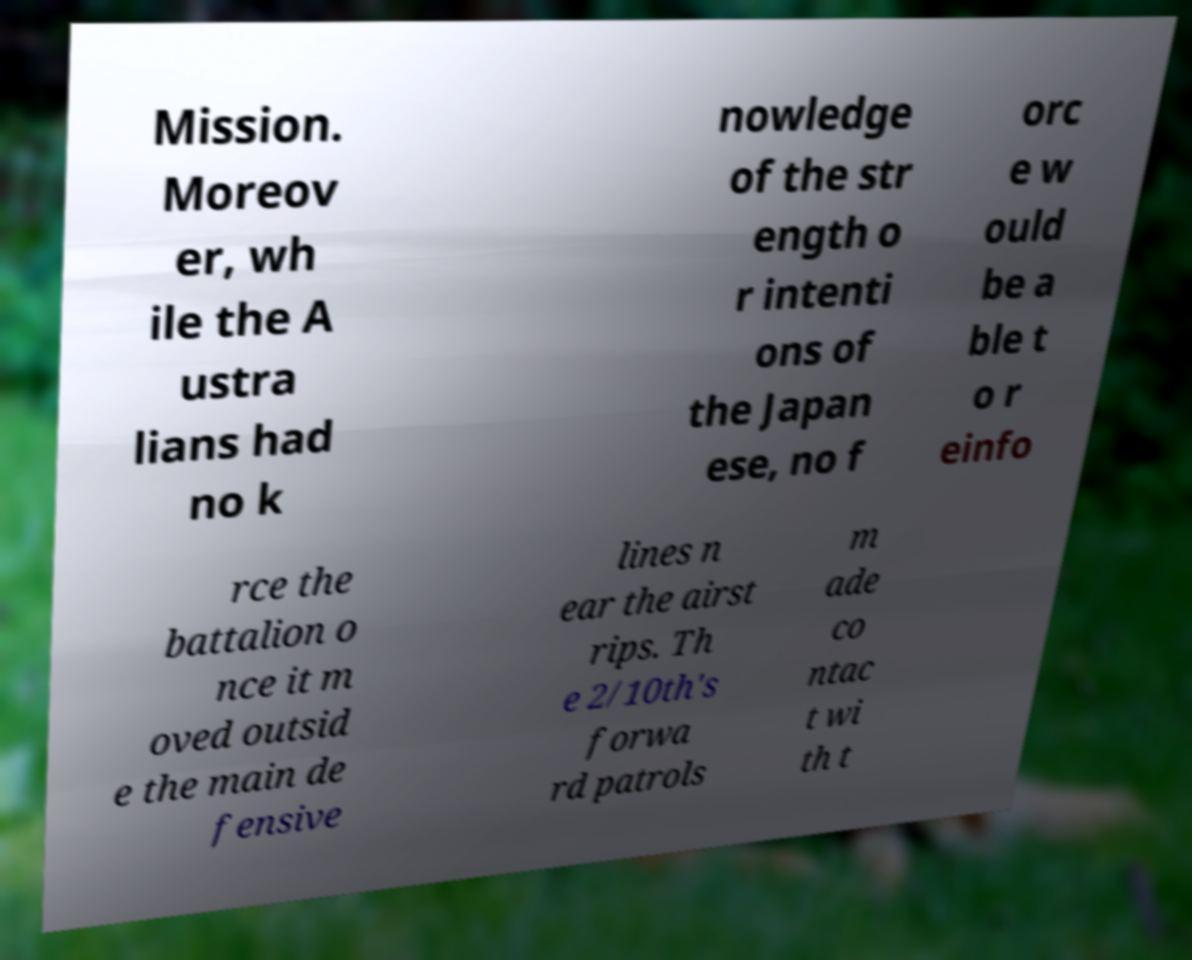What messages or text are displayed in this image? I need them in a readable, typed format. Mission. Moreov er, wh ile the A ustra lians had no k nowledge of the str ength o r intenti ons of the Japan ese, no f orc e w ould be a ble t o r einfo rce the battalion o nce it m oved outsid e the main de fensive lines n ear the airst rips. Th e 2/10th's forwa rd patrols m ade co ntac t wi th t 